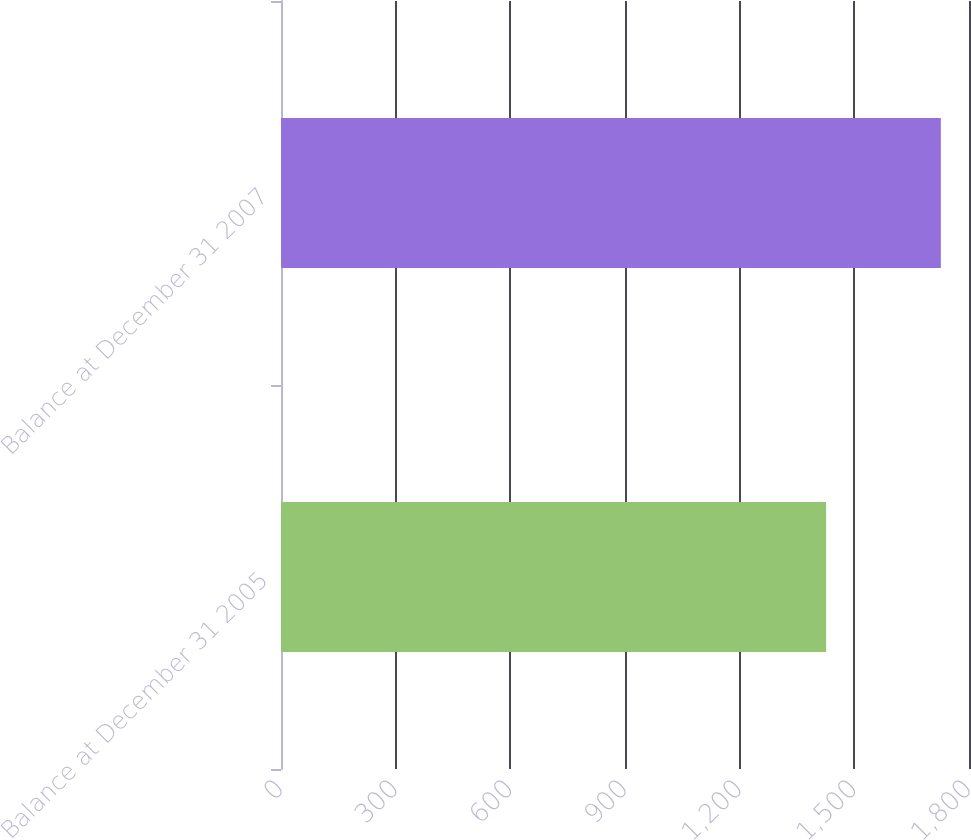<chart> <loc_0><loc_0><loc_500><loc_500><bar_chart><fcel>Balance at December 31 2005<fcel>Balance at December 31 2007<nl><fcel>1426.2<fcel>1726.3<nl></chart> 